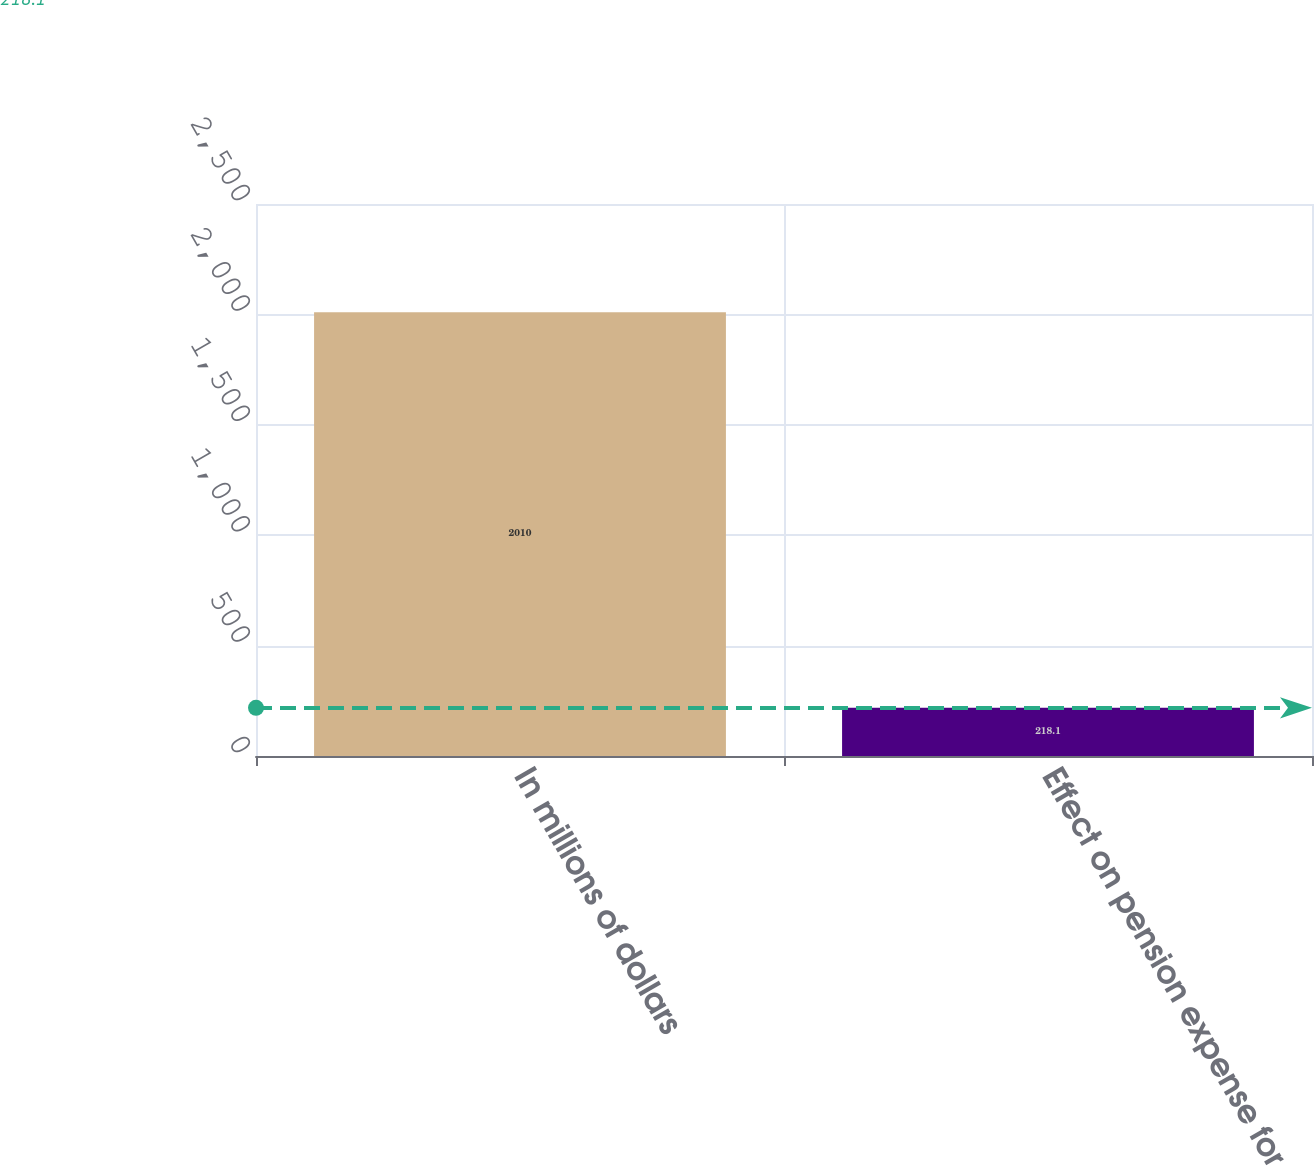<chart> <loc_0><loc_0><loc_500><loc_500><bar_chart><fcel>In millions of dollars<fcel>Effect on pension expense for<nl><fcel>2010<fcel>218.1<nl></chart> 